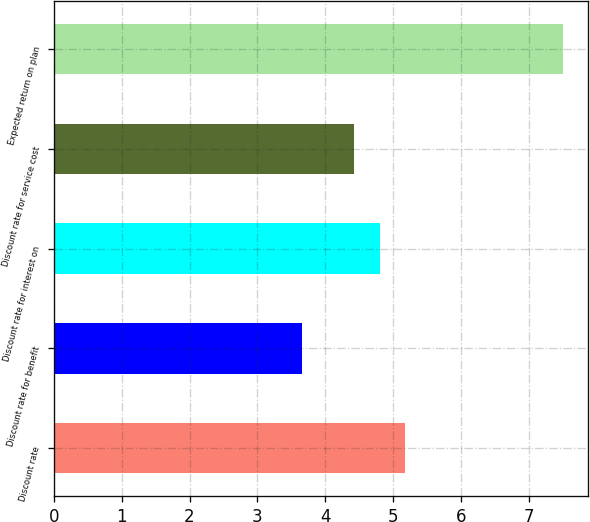Convert chart. <chart><loc_0><loc_0><loc_500><loc_500><bar_chart><fcel>Discount rate<fcel>Discount rate for benefit<fcel>Discount rate for interest on<fcel>Discount rate for service cost<fcel>Expected return on plan<nl><fcel>5.18<fcel>3.66<fcel>4.8<fcel>4.42<fcel>7.5<nl></chart> 